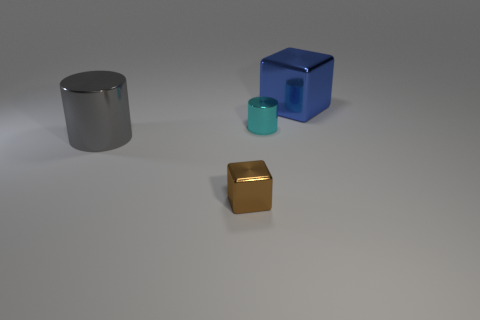Subtract all red cubes. Subtract all purple cylinders. How many cubes are left? 2 Subtract all purple blocks. How many blue cylinders are left? 0 Add 4 objects. How many small browns exist? 0 Subtract all large gray shiny objects. Subtract all gray cylinders. How many objects are left? 2 Add 3 tiny shiny objects. How many tiny shiny objects are left? 5 Add 2 large gray metallic objects. How many large gray metallic objects exist? 3 Add 4 gray metallic cylinders. How many objects exist? 8 Subtract all cyan cylinders. How many cylinders are left? 1 Subtract 0 yellow cubes. How many objects are left? 4 Subtract 1 cubes. How many cubes are left? 1 